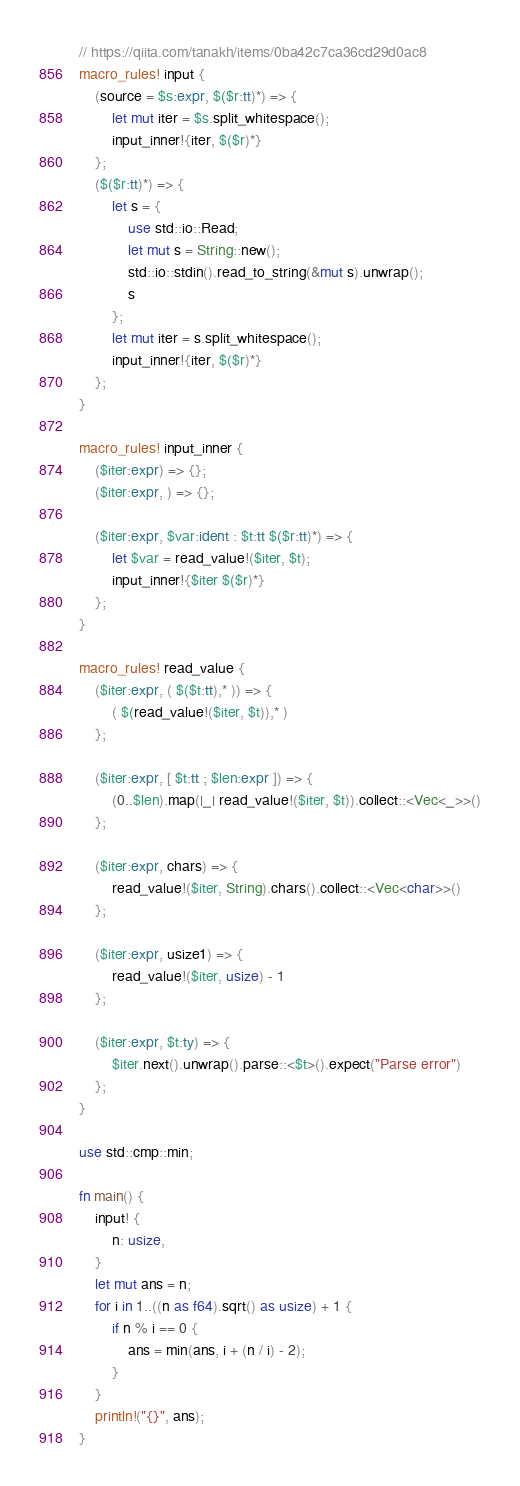<code> <loc_0><loc_0><loc_500><loc_500><_Rust_>// https://qiita.com/tanakh/items/0ba42c7ca36cd29d0ac8
macro_rules! input {
    (source = $s:expr, $($r:tt)*) => {
        let mut iter = $s.split_whitespace();
        input_inner!{iter, $($r)*}
    };
    ($($r:tt)*) => {
        let s = {
            use std::io::Read;
            let mut s = String::new();
            std::io::stdin().read_to_string(&mut s).unwrap();
            s
        };
        let mut iter = s.split_whitespace();
        input_inner!{iter, $($r)*}
    };
}

macro_rules! input_inner {
    ($iter:expr) => {};
    ($iter:expr, ) => {};

    ($iter:expr, $var:ident : $t:tt $($r:tt)*) => {
        let $var = read_value!($iter, $t);
        input_inner!{$iter $($r)*}
    };
}

macro_rules! read_value {
    ($iter:expr, ( $($t:tt),* )) => {
        ( $(read_value!($iter, $t)),* )
    };

    ($iter:expr, [ $t:tt ; $len:expr ]) => {
        (0..$len).map(|_| read_value!($iter, $t)).collect::<Vec<_>>()
    };

    ($iter:expr, chars) => {
        read_value!($iter, String).chars().collect::<Vec<char>>()
    };

    ($iter:expr, usize1) => {
        read_value!($iter, usize) - 1
    };

    ($iter:expr, $t:ty) => {
        $iter.next().unwrap().parse::<$t>().expect("Parse error")
    };
}

use std::cmp::min;

fn main() {
    input! {
        n: usize,
    }
    let mut ans = n;
    for i in 1..((n as f64).sqrt() as usize) + 1 {
        if n % i == 0 {
            ans = min(ans, i + (n / i) - 2);
        }
    }
    println!("{}", ans);
}
</code> 